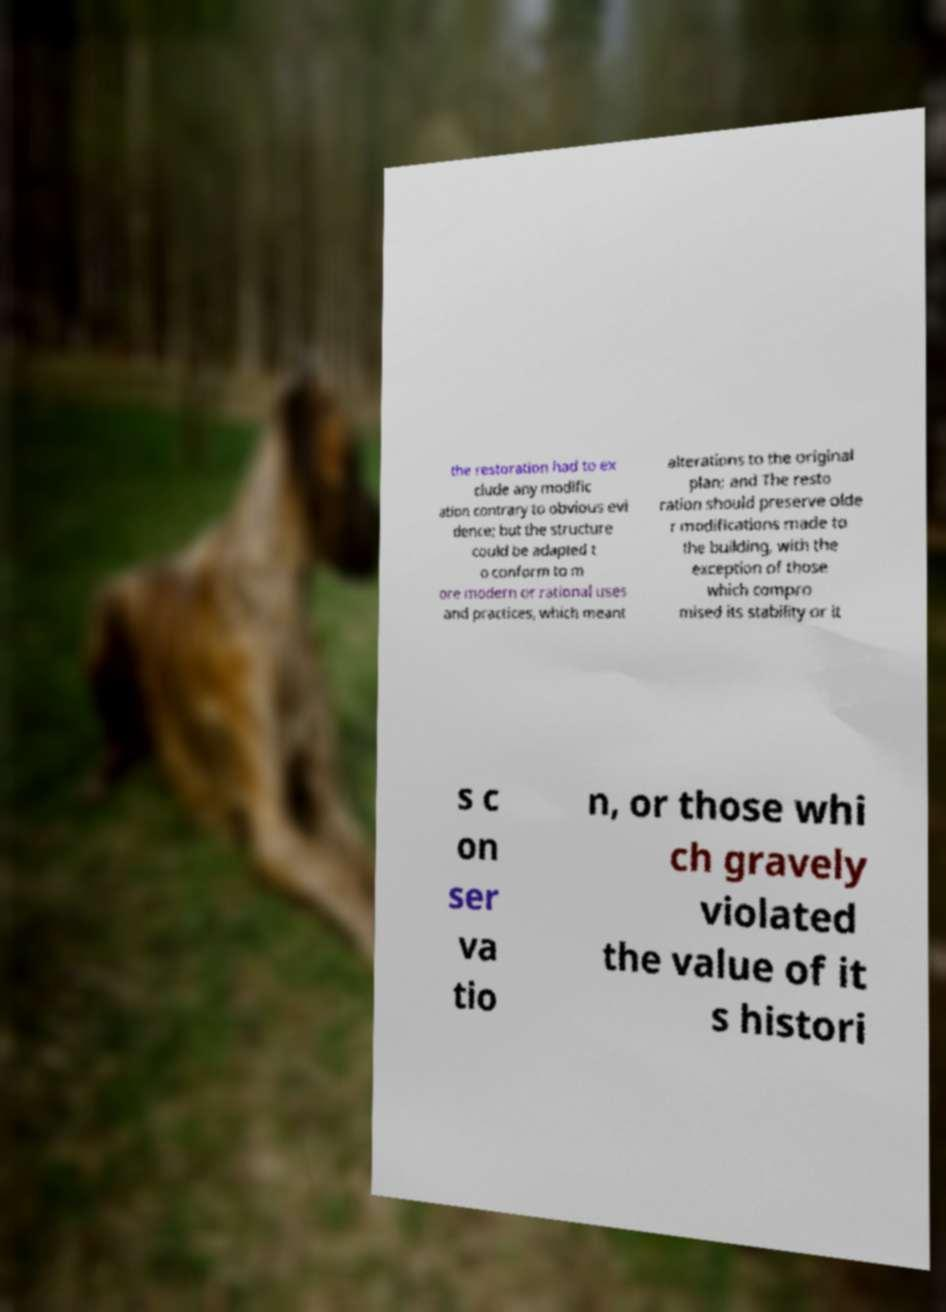Please identify and transcribe the text found in this image. the restoration had to ex clude any modific ation contrary to obvious evi dence; but the structure could be adapted t o conform to m ore modern or rational uses and practices, which meant alterations to the original plan; and The resto ration should preserve olde r modifications made to the building, with the exception of those which compro mised its stability or it s c on ser va tio n, or those whi ch gravely violated the value of it s histori 